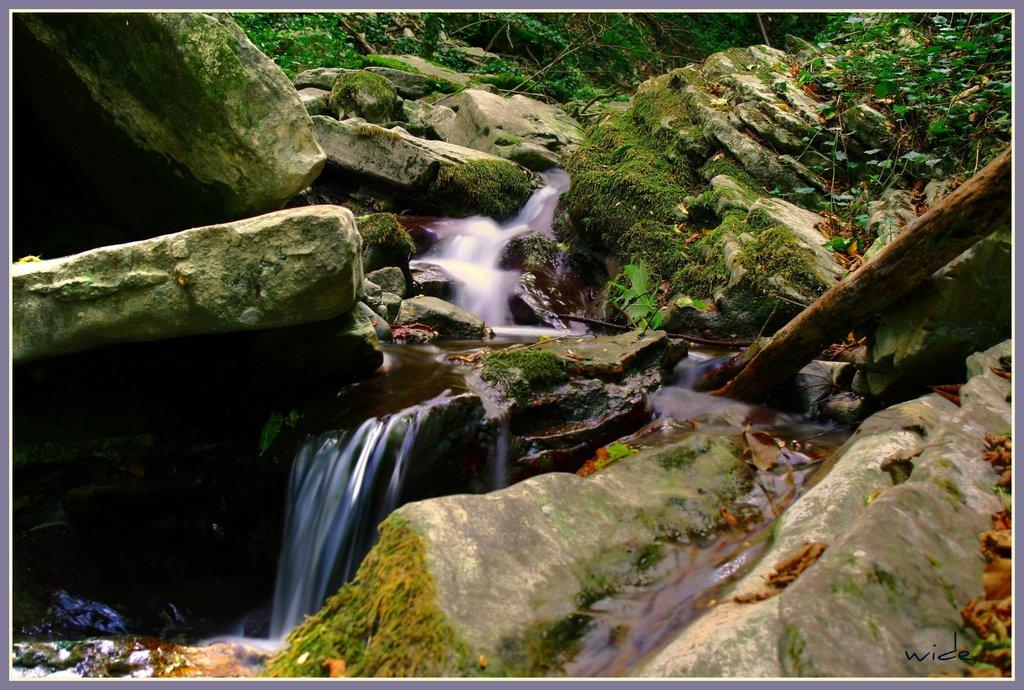What natural feature is the main subject of the image? There is a waterfall in the image. What other elements can be seen in the image? There are rocks, plants, grass, and a wooden pole visible in the image. Where is the text located in the image? The text is in the bottom right corner of the image. How many icicles are hanging from the wooden pole in the image? There are no icicles present in the image; it features a waterfall, rocks, plants, grass, and a wooden pole, but no icicles. What type of curtain can be seen in the image? There is no curtain present in the image. 